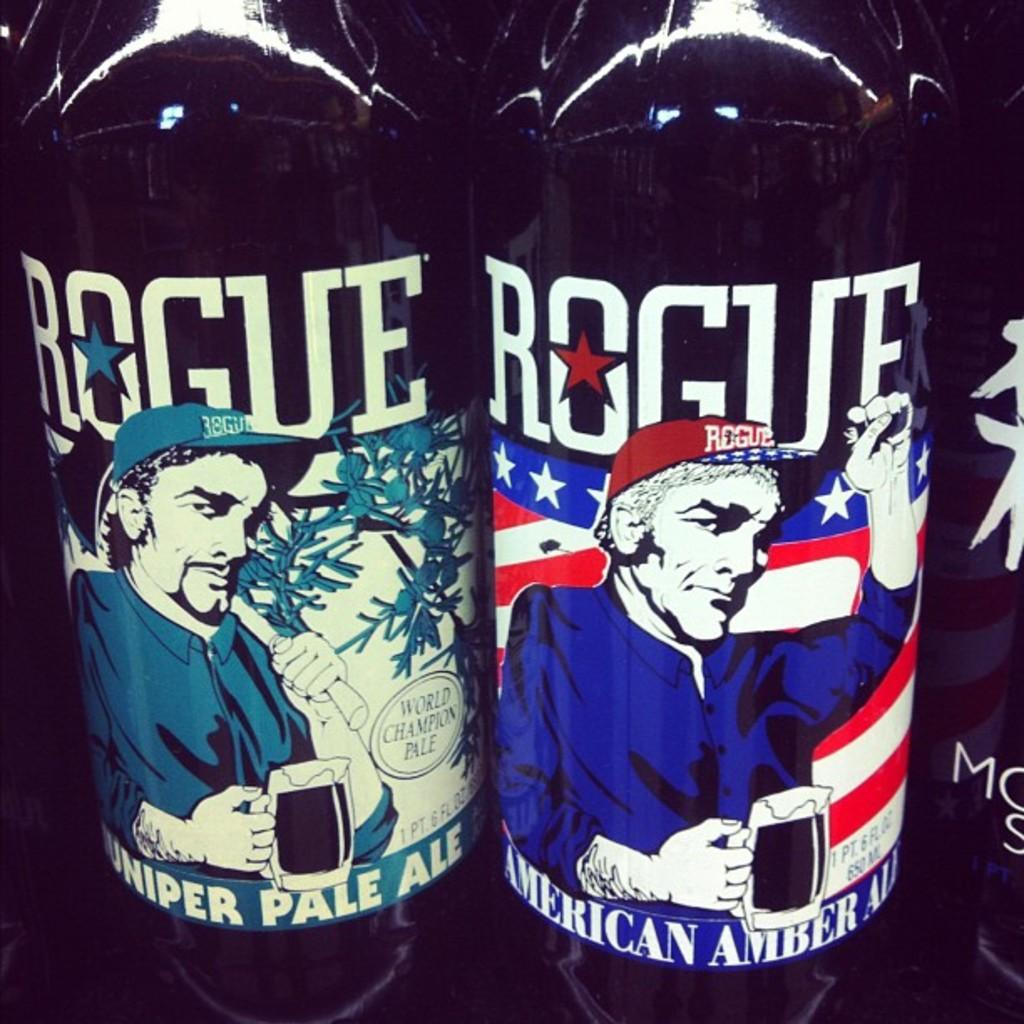<image>
Write a terse but informative summary of the picture. Two cans of Juniper Pale Ale and American Amber Ale 